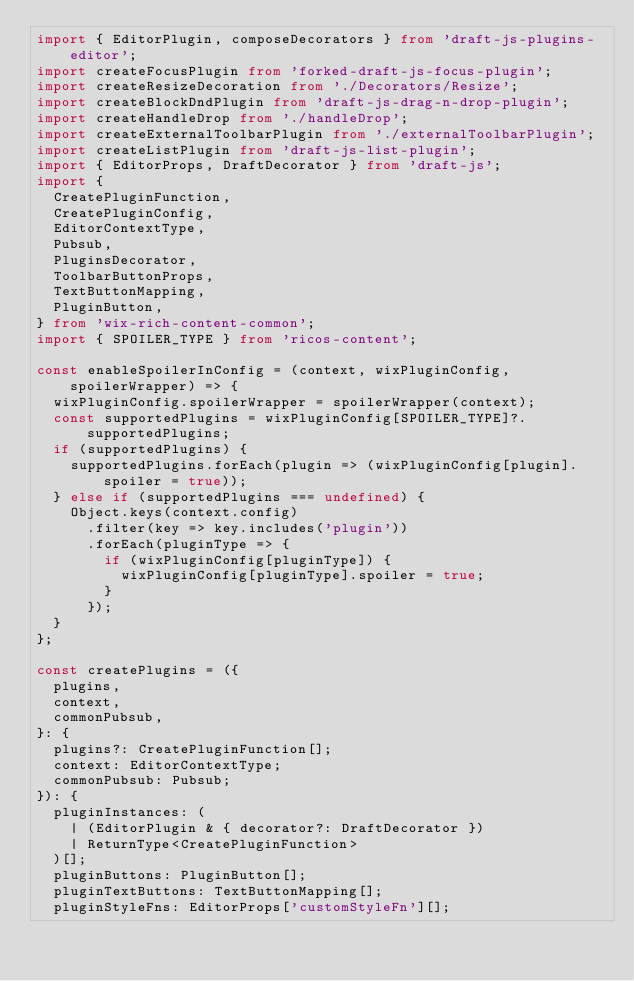<code> <loc_0><loc_0><loc_500><loc_500><_TypeScript_>import { EditorPlugin, composeDecorators } from 'draft-js-plugins-editor';
import createFocusPlugin from 'forked-draft-js-focus-plugin';
import createResizeDecoration from './Decorators/Resize';
import createBlockDndPlugin from 'draft-js-drag-n-drop-plugin';
import createHandleDrop from './handleDrop';
import createExternalToolbarPlugin from './externalToolbarPlugin';
import createListPlugin from 'draft-js-list-plugin';
import { EditorProps, DraftDecorator } from 'draft-js';
import {
  CreatePluginFunction,
  CreatePluginConfig,
  EditorContextType,
  Pubsub,
  PluginsDecorator,
  ToolbarButtonProps,
  TextButtonMapping,
  PluginButton,
} from 'wix-rich-content-common';
import { SPOILER_TYPE } from 'ricos-content';

const enableSpoilerInConfig = (context, wixPluginConfig, spoilerWrapper) => {
  wixPluginConfig.spoilerWrapper = spoilerWrapper(context);
  const supportedPlugins = wixPluginConfig[SPOILER_TYPE]?.supportedPlugins;
  if (supportedPlugins) {
    supportedPlugins.forEach(plugin => (wixPluginConfig[plugin].spoiler = true));
  } else if (supportedPlugins === undefined) {
    Object.keys(context.config)
      .filter(key => key.includes('plugin'))
      .forEach(pluginType => {
        if (wixPluginConfig[pluginType]) {
          wixPluginConfig[pluginType].spoiler = true;
        }
      });
  }
};

const createPlugins = ({
  plugins,
  context,
  commonPubsub,
}: {
  plugins?: CreatePluginFunction[];
  context: EditorContextType;
  commonPubsub: Pubsub;
}): {
  pluginInstances: (
    | (EditorPlugin & { decorator?: DraftDecorator })
    | ReturnType<CreatePluginFunction>
  )[];
  pluginButtons: PluginButton[];
  pluginTextButtons: TextButtonMapping[];
  pluginStyleFns: EditorProps['customStyleFn'][];</code> 